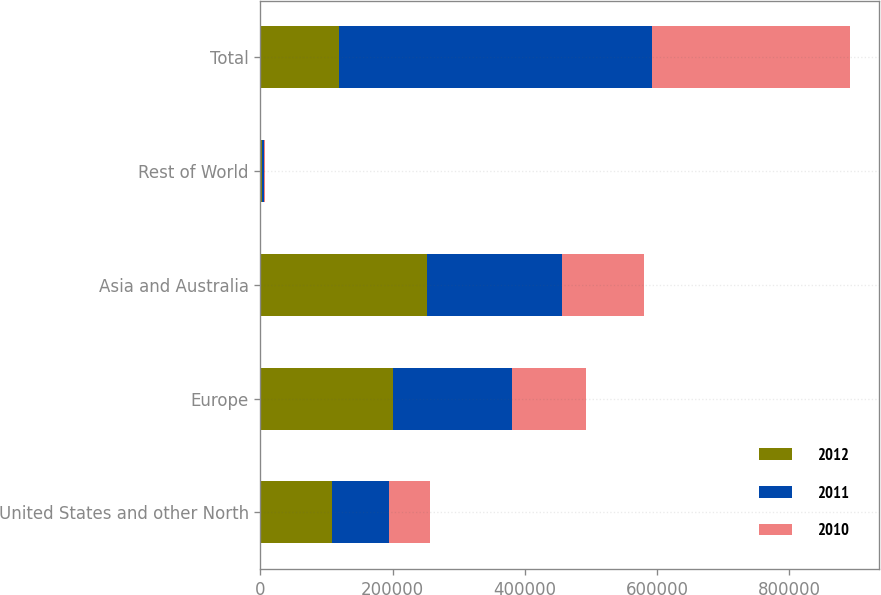Convert chart to OTSL. <chart><loc_0><loc_0><loc_500><loc_500><stacked_bar_chart><ecel><fcel>United States and other North<fcel>Europe<fcel>Asia and Australia<fcel>Rest of World<fcel>Total<nl><fcel>2012<fcel>108316<fcel>200708<fcel>251803<fcel>1701<fcel>118355<nl><fcel>2011<fcel>86181<fcel>179584<fcel>204758<fcel>3959<fcel>474482<nl><fcel>2010<fcel>61706<fcel>112456<fcel>124254<fcel>840<fcel>299256<nl></chart> 